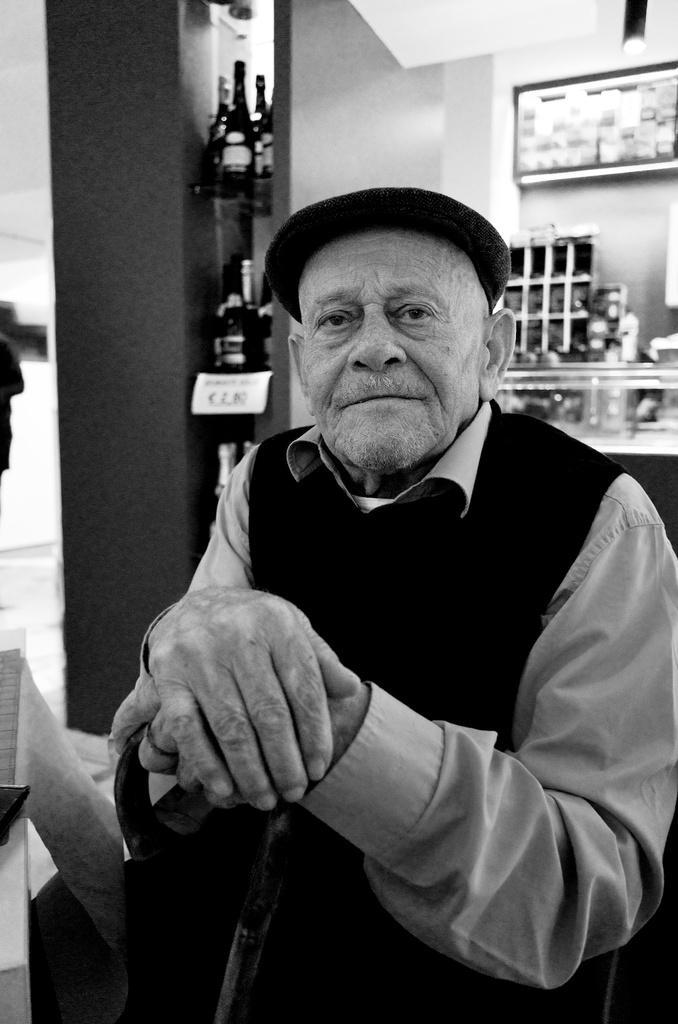Could you give a brief overview of what you see in this image? It is the black and white image of an old man. In the background there are wines bottles kept in the shelf. The old man is holding the walking stick. In the background there are cupboards. 